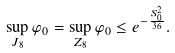<formula> <loc_0><loc_0><loc_500><loc_500>\sup _ { J _ { 8 } } \varphi _ { 0 } = \sup _ { Z _ { 8 } } \varphi _ { 0 } \leq e ^ { - \frac { S _ { 0 } ^ { 2 } } { 3 6 } } .</formula> 